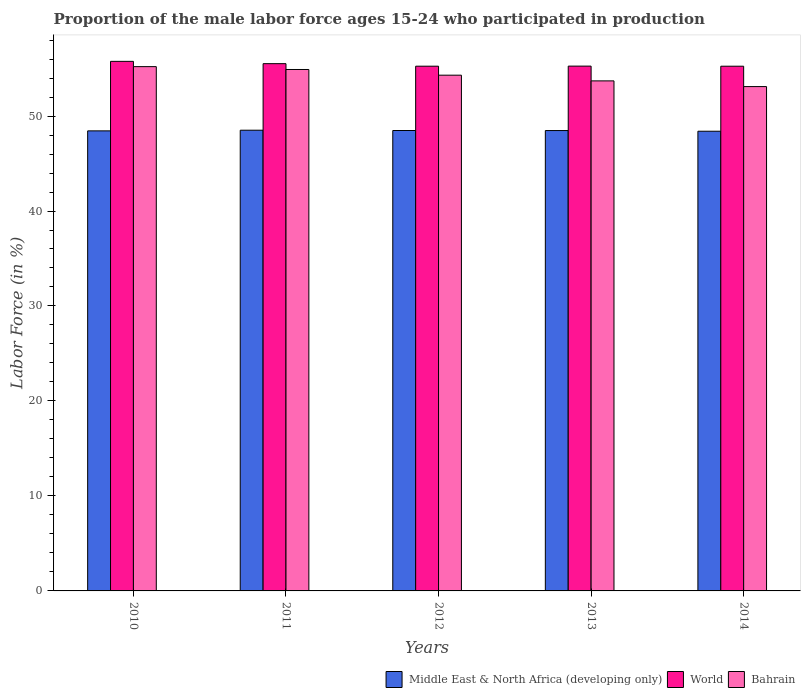How many different coloured bars are there?
Offer a very short reply. 3. Are the number of bars per tick equal to the number of legend labels?
Offer a very short reply. Yes. How many bars are there on the 2nd tick from the right?
Your answer should be very brief. 3. What is the label of the 3rd group of bars from the left?
Provide a short and direct response. 2012. What is the proportion of the male labor force who participated in production in Bahrain in 2014?
Provide a succinct answer. 53.1. Across all years, what is the maximum proportion of the male labor force who participated in production in Middle East & North Africa (developing only)?
Your response must be concise. 48.51. Across all years, what is the minimum proportion of the male labor force who participated in production in Bahrain?
Ensure brevity in your answer.  53.1. In which year was the proportion of the male labor force who participated in production in Middle East & North Africa (developing only) minimum?
Your answer should be very brief. 2014. What is the total proportion of the male labor force who participated in production in Bahrain in the graph?
Keep it short and to the point. 271.2. What is the difference between the proportion of the male labor force who participated in production in Middle East & North Africa (developing only) in 2013 and that in 2014?
Make the answer very short. 0.07. What is the difference between the proportion of the male labor force who participated in production in Bahrain in 2011 and the proportion of the male labor force who participated in production in World in 2014?
Your response must be concise. -0.34. What is the average proportion of the male labor force who participated in production in Middle East & North Africa (developing only) per year?
Make the answer very short. 48.46. In the year 2012, what is the difference between the proportion of the male labor force who participated in production in Middle East & North Africa (developing only) and proportion of the male labor force who participated in production in Bahrain?
Your answer should be very brief. -5.82. What is the ratio of the proportion of the male labor force who participated in production in Middle East & North Africa (developing only) in 2013 to that in 2014?
Ensure brevity in your answer.  1. Is the difference between the proportion of the male labor force who participated in production in Middle East & North Africa (developing only) in 2011 and 2014 greater than the difference between the proportion of the male labor force who participated in production in Bahrain in 2011 and 2014?
Provide a short and direct response. No. What is the difference between the highest and the second highest proportion of the male labor force who participated in production in Bahrain?
Keep it short and to the point. 0.3. What is the difference between the highest and the lowest proportion of the male labor force who participated in production in Bahrain?
Your answer should be very brief. 2.1. What does the 3rd bar from the left in 2012 represents?
Offer a terse response. Bahrain. What does the 2nd bar from the right in 2013 represents?
Provide a succinct answer. World. Is it the case that in every year, the sum of the proportion of the male labor force who participated in production in World and proportion of the male labor force who participated in production in Bahrain is greater than the proportion of the male labor force who participated in production in Middle East & North Africa (developing only)?
Your answer should be compact. Yes. How many years are there in the graph?
Your answer should be compact. 5. What is the difference between two consecutive major ticks on the Y-axis?
Your answer should be very brief. 10. Are the values on the major ticks of Y-axis written in scientific E-notation?
Make the answer very short. No. How many legend labels are there?
Offer a very short reply. 3. What is the title of the graph?
Keep it short and to the point. Proportion of the male labor force ages 15-24 who participated in production. Does "Norway" appear as one of the legend labels in the graph?
Provide a short and direct response. No. What is the label or title of the X-axis?
Your answer should be very brief. Years. What is the label or title of the Y-axis?
Ensure brevity in your answer.  Labor Force (in %). What is the Labor Force (in %) in Middle East & North Africa (developing only) in 2010?
Your answer should be very brief. 48.44. What is the Labor Force (in %) in World in 2010?
Your answer should be compact. 55.76. What is the Labor Force (in %) in Bahrain in 2010?
Ensure brevity in your answer.  55.2. What is the Labor Force (in %) in Middle East & North Africa (developing only) in 2011?
Ensure brevity in your answer.  48.51. What is the Labor Force (in %) of World in 2011?
Your response must be concise. 55.51. What is the Labor Force (in %) of Bahrain in 2011?
Keep it short and to the point. 54.9. What is the Labor Force (in %) of Middle East & North Africa (developing only) in 2012?
Provide a short and direct response. 48.48. What is the Labor Force (in %) in World in 2012?
Ensure brevity in your answer.  55.25. What is the Labor Force (in %) in Bahrain in 2012?
Your answer should be very brief. 54.3. What is the Labor Force (in %) in Middle East & North Africa (developing only) in 2013?
Your answer should be compact. 48.47. What is the Labor Force (in %) in World in 2013?
Make the answer very short. 55.26. What is the Labor Force (in %) in Bahrain in 2013?
Provide a short and direct response. 53.7. What is the Labor Force (in %) of Middle East & North Africa (developing only) in 2014?
Your answer should be compact. 48.4. What is the Labor Force (in %) in World in 2014?
Offer a terse response. 55.24. What is the Labor Force (in %) in Bahrain in 2014?
Give a very brief answer. 53.1. Across all years, what is the maximum Labor Force (in %) of Middle East & North Africa (developing only)?
Your answer should be very brief. 48.51. Across all years, what is the maximum Labor Force (in %) of World?
Provide a short and direct response. 55.76. Across all years, what is the maximum Labor Force (in %) of Bahrain?
Provide a succinct answer. 55.2. Across all years, what is the minimum Labor Force (in %) of Middle East & North Africa (developing only)?
Keep it short and to the point. 48.4. Across all years, what is the minimum Labor Force (in %) in World?
Provide a short and direct response. 55.24. Across all years, what is the minimum Labor Force (in %) of Bahrain?
Your answer should be very brief. 53.1. What is the total Labor Force (in %) of Middle East & North Africa (developing only) in the graph?
Your answer should be very brief. 242.29. What is the total Labor Force (in %) of World in the graph?
Provide a succinct answer. 277.02. What is the total Labor Force (in %) of Bahrain in the graph?
Give a very brief answer. 271.2. What is the difference between the Labor Force (in %) of Middle East & North Africa (developing only) in 2010 and that in 2011?
Ensure brevity in your answer.  -0.07. What is the difference between the Labor Force (in %) of World in 2010 and that in 2011?
Your answer should be very brief. 0.24. What is the difference between the Labor Force (in %) in Bahrain in 2010 and that in 2011?
Make the answer very short. 0.3. What is the difference between the Labor Force (in %) in Middle East & North Africa (developing only) in 2010 and that in 2012?
Provide a succinct answer. -0.04. What is the difference between the Labor Force (in %) in World in 2010 and that in 2012?
Keep it short and to the point. 0.51. What is the difference between the Labor Force (in %) of Bahrain in 2010 and that in 2012?
Your response must be concise. 0.9. What is the difference between the Labor Force (in %) in Middle East & North Africa (developing only) in 2010 and that in 2013?
Your answer should be compact. -0.03. What is the difference between the Labor Force (in %) of World in 2010 and that in 2013?
Offer a very short reply. 0.5. What is the difference between the Labor Force (in %) of Bahrain in 2010 and that in 2013?
Provide a short and direct response. 1.5. What is the difference between the Labor Force (in %) in Middle East & North Africa (developing only) in 2010 and that in 2014?
Give a very brief answer. 0.04. What is the difference between the Labor Force (in %) in World in 2010 and that in 2014?
Keep it short and to the point. 0.51. What is the difference between the Labor Force (in %) in Middle East & North Africa (developing only) in 2011 and that in 2012?
Keep it short and to the point. 0.03. What is the difference between the Labor Force (in %) in World in 2011 and that in 2012?
Provide a short and direct response. 0.27. What is the difference between the Labor Force (in %) in Bahrain in 2011 and that in 2012?
Your answer should be very brief. 0.6. What is the difference between the Labor Force (in %) of Middle East & North Africa (developing only) in 2011 and that in 2013?
Provide a succinct answer. 0.04. What is the difference between the Labor Force (in %) in World in 2011 and that in 2013?
Offer a very short reply. 0.26. What is the difference between the Labor Force (in %) in Middle East & North Africa (developing only) in 2011 and that in 2014?
Your answer should be very brief. 0.11. What is the difference between the Labor Force (in %) in World in 2011 and that in 2014?
Keep it short and to the point. 0.27. What is the difference between the Labor Force (in %) of Middle East & North Africa (developing only) in 2012 and that in 2013?
Give a very brief answer. 0.01. What is the difference between the Labor Force (in %) of World in 2012 and that in 2013?
Provide a succinct answer. -0.01. What is the difference between the Labor Force (in %) in Middle East & North Africa (developing only) in 2012 and that in 2014?
Give a very brief answer. 0.08. What is the difference between the Labor Force (in %) of World in 2012 and that in 2014?
Ensure brevity in your answer.  0. What is the difference between the Labor Force (in %) in Bahrain in 2012 and that in 2014?
Give a very brief answer. 1.2. What is the difference between the Labor Force (in %) in Middle East & North Africa (developing only) in 2013 and that in 2014?
Offer a very short reply. 0.07. What is the difference between the Labor Force (in %) in World in 2013 and that in 2014?
Provide a short and direct response. 0.01. What is the difference between the Labor Force (in %) in Bahrain in 2013 and that in 2014?
Keep it short and to the point. 0.6. What is the difference between the Labor Force (in %) of Middle East & North Africa (developing only) in 2010 and the Labor Force (in %) of World in 2011?
Your answer should be very brief. -7.08. What is the difference between the Labor Force (in %) of Middle East & North Africa (developing only) in 2010 and the Labor Force (in %) of Bahrain in 2011?
Ensure brevity in your answer.  -6.46. What is the difference between the Labor Force (in %) of World in 2010 and the Labor Force (in %) of Bahrain in 2011?
Keep it short and to the point. 0.86. What is the difference between the Labor Force (in %) of Middle East & North Africa (developing only) in 2010 and the Labor Force (in %) of World in 2012?
Ensure brevity in your answer.  -6.81. What is the difference between the Labor Force (in %) of Middle East & North Africa (developing only) in 2010 and the Labor Force (in %) of Bahrain in 2012?
Your answer should be compact. -5.86. What is the difference between the Labor Force (in %) of World in 2010 and the Labor Force (in %) of Bahrain in 2012?
Give a very brief answer. 1.46. What is the difference between the Labor Force (in %) of Middle East & North Africa (developing only) in 2010 and the Labor Force (in %) of World in 2013?
Offer a very short reply. -6.82. What is the difference between the Labor Force (in %) of Middle East & North Africa (developing only) in 2010 and the Labor Force (in %) of Bahrain in 2013?
Give a very brief answer. -5.26. What is the difference between the Labor Force (in %) of World in 2010 and the Labor Force (in %) of Bahrain in 2013?
Offer a terse response. 2.06. What is the difference between the Labor Force (in %) in Middle East & North Africa (developing only) in 2010 and the Labor Force (in %) in World in 2014?
Make the answer very short. -6.81. What is the difference between the Labor Force (in %) in Middle East & North Africa (developing only) in 2010 and the Labor Force (in %) in Bahrain in 2014?
Give a very brief answer. -4.66. What is the difference between the Labor Force (in %) in World in 2010 and the Labor Force (in %) in Bahrain in 2014?
Keep it short and to the point. 2.66. What is the difference between the Labor Force (in %) of Middle East & North Africa (developing only) in 2011 and the Labor Force (in %) of World in 2012?
Offer a very short reply. -6.74. What is the difference between the Labor Force (in %) in Middle East & North Africa (developing only) in 2011 and the Labor Force (in %) in Bahrain in 2012?
Your answer should be compact. -5.79. What is the difference between the Labor Force (in %) in World in 2011 and the Labor Force (in %) in Bahrain in 2012?
Provide a succinct answer. 1.21. What is the difference between the Labor Force (in %) in Middle East & North Africa (developing only) in 2011 and the Labor Force (in %) in World in 2013?
Your response must be concise. -6.75. What is the difference between the Labor Force (in %) in Middle East & North Africa (developing only) in 2011 and the Labor Force (in %) in Bahrain in 2013?
Make the answer very short. -5.19. What is the difference between the Labor Force (in %) of World in 2011 and the Labor Force (in %) of Bahrain in 2013?
Offer a very short reply. 1.81. What is the difference between the Labor Force (in %) in Middle East & North Africa (developing only) in 2011 and the Labor Force (in %) in World in 2014?
Offer a terse response. -6.74. What is the difference between the Labor Force (in %) of Middle East & North Africa (developing only) in 2011 and the Labor Force (in %) of Bahrain in 2014?
Your answer should be compact. -4.59. What is the difference between the Labor Force (in %) in World in 2011 and the Labor Force (in %) in Bahrain in 2014?
Provide a short and direct response. 2.41. What is the difference between the Labor Force (in %) of Middle East & North Africa (developing only) in 2012 and the Labor Force (in %) of World in 2013?
Your answer should be very brief. -6.78. What is the difference between the Labor Force (in %) in Middle East & North Africa (developing only) in 2012 and the Labor Force (in %) in Bahrain in 2013?
Give a very brief answer. -5.22. What is the difference between the Labor Force (in %) in World in 2012 and the Labor Force (in %) in Bahrain in 2013?
Give a very brief answer. 1.55. What is the difference between the Labor Force (in %) in Middle East & North Africa (developing only) in 2012 and the Labor Force (in %) in World in 2014?
Ensure brevity in your answer.  -6.77. What is the difference between the Labor Force (in %) of Middle East & North Africa (developing only) in 2012 and the Labor Force (in %) of Bahrain in 2014?
Ensure brevity in your answer.  -4.62. What is the difference between the Labor Force (in %) of World in 2012 and the Labor Force (in %) of Bahrain in 2014?
Keep it short and to the point. 2.15. What is the difference between the Labor Force (in %) in Middle East & North Africa (developing only) in 2013 and the Labor Force (in %) in World in 2014?
Offer a terse response. -6.77. What is the difference between the Labor Force (in %) in Middle East & North Africa (developing only) in 2013 and the Labor Force (in %) in Bahrain in 2014?
Keep it short and to the point. -4.63. What is the difference between the Labor Force (in %) in World in 2013 and the Labor Force (in %) in Bahrain in 2014?
Offer a terse response. 2.16. What is the average Labor Force (in %) in Middle East & North Africa (developing only) per year?
Ensure brevity in your answer.  48.46. What is the average Labor Force (in %) in World per year?
Your response must be concise. 55.4. What is the average Labor Force (in %) of Bahrain per year?
Keep it short and to the point. 54.24. In the year 2010, what is the difference between the Labor Force (in %) in Middle East & North Africa (developing only) and Labor Force (in %) in World?
Your response must be concise. -7.32. In the year 2010, what is the difference between the Labor Force (in %) in Middle East & North Africa (developing only) and Labor Force (in %) in Bahrain?
Give a very brief answer. -6.76. In the year 2010, what is the difference between the Labor Force (in %) in World and Labor Force (in %) in Bahrain?
Your answer should be very brief. 0.56. In the year 2011, what is the difference between the Labor Force (in %) of Middle East & North Africa (developing only) and Labor Force (in %) of World?
Provide a short and direct response. -7.01. In the year 2011, what is the difference between the Labor Force (in %) of Middle East & North Africa (developing only) and Labor Force (in %) of Bahrain?
Ensure brevity in your answer.  -6.39. In the year 2011, what is the difference between the Labor Force (in %) of World and Labor Force (in %) of Bahrain?
Ensure brevity in your answer.  0.61. In the year 2012, what is the difference between the Labor Force (in %) of Middle East & North Africa (developing only) and Labor Force (in %) of World?
Make the answer very short. -6.77. In the year 2012, what is the difference between the Labor Force (in %) in Middle East & North Africa (developing only) and Labor Force (in %) in Bahrain?
Your answer should be compact. -5.82. In the year 2012, what is the difference between the Labor Force (in %) in World and Labor Force (in %) in Bahrain?
Offer a terse response. 0.95. In the year 2013, what is the difference between the Labor Force (in %) of Middle East & North Africa (developing only) and Labor Force (in %) of World?
Keep it short and to the point. -6.78. In the year 2013, what is the difference between the Labor Force (in %) in Middle East & North Africa (developing only) and Labor Force (in %) in Bahrain?
Make the answer very short. -5.23. In the year 2013, what is the difference between the Labor Force (in %) of World and Labor Force (in %) of Bahrain?
Offer a very short reply. 1.56. In the year 2014, what is the difference between the Labor Force (in %) of Middle East & North Africa (developing only) and Labor Force (in %) of World?
Provide a short and direct response. -6.85. In the year 2014, what is the difference between the Labor Force (in %) of Middle East & North Africa (developing only) and Labor Force (in %) of Bahrain?
Give a very brief answer. -4.7. In the year 2014, what is the difference between the Labor Force (in %) of World and Labor Force (in %) of Bahrain?
Offer a very short reply. 2.14. What is the ratio of the Labor Force (in %) in Middle East & North Africa (developing only) in 2010 to that in 2011?
Offer a terse response. 1. What is the ratio of the Labor Force (in %) in World in 2010 to that in 2011?
Your answer should be compact. 1. What is the ratio of the Labor Force (in %) of Bahrain in 2010 to that in 2011?
Make the answer very short. 1.01. What is the ratio of the Labor Force (in %) of Middle East & North Africa (developing only) in 2010 to that in 2012?
Keep it short and to the point. 1. What is the ratio of the Labor Force (in %) of World in 2010 to that in 2012?
Your answer should be very brief. 1.01. What is the ratio of the Labor Force (in %) of Bahrain in 2010 to that in 2012?
Your answer should be compact. 1.02. What is the ratio of the Labor Force (in %) of World in 2010 to that in 2013?
Offer a terse response. 1.01. What is the ratio of the Labor Force (in %) in Bahrain in 2010 to that in 2013?
Offer a terse response. 1.03. What is the ratio of the Labor Force (in %) in World in 2010 to that in 2014?
Make the answer very short. 1.01. What is the ratio of the Labor Force (in %) in Bahrain in 2010 to that in 2014?
Give a very brief answer. 1.04. What is the ratio of the Labor Force (in %) in World in 2011 to that in 2012?
Offer a terse response. 1. What is the ratio of the Labor Force (in %) of Bahrain in 2011 to that in 2013?
Offer a very short reply. 1.02. What is the ratio of the Labor Force (in %) of Middle East & North Africa (developing only) in 2011 to that in 2014?
Your answer should be very brief. 1. What is the ratio of the Labor Force (in %) of Bahrain in 2011 to that in 2014?
Keep it short and to the point. 1.03. What is the ratio of the Labor Force (in %) in World in 2012 to that in 2013?
Your answer should be compact. 1. What is the ratio of the Labor Force (in %) in Bahrain in 2012 to that in 2013?
Provide a succinct answer. 1.01. What is the ratio of the Labor Force (in %) of Bahrain in 2012 to that in 2014?
Provide a short and direct response. 1.02. What is the ratio of the Labor Force (in %) of World in 2013 to that in 2014?
Offer a very short reply. 1. What is the ratio of the Labor Force (in %) in Bahrain in 2013 to that in 2014?
Your answer should be compact. 1.01. What is the difference between the highest and the second highest Labor Force (in %) of Middle East & North Africa (developing only)?
Provide a succinct answer. 0.03. What is the difference between the highest and the second highest Labor Force (in %) in World?
Your response must be concise. 0.24. What is the difference between the highest and the second highest Labor Force (in %) of Bahrain?
Your answer should be very brief. 0.3. What is the difference between the highest and the lowest Labor Force (in %) in Middle East & North Africa (developing only)?
Give a very brief answer. 0.11. What is the difference between the highest and the lowest Labor Force (in %) in World?
Provide a succinct answer. 0.51. What is the difference between the highest and the lowest Labor Force (in %) in Bahrain?
Make the answer very short. 2.1. 